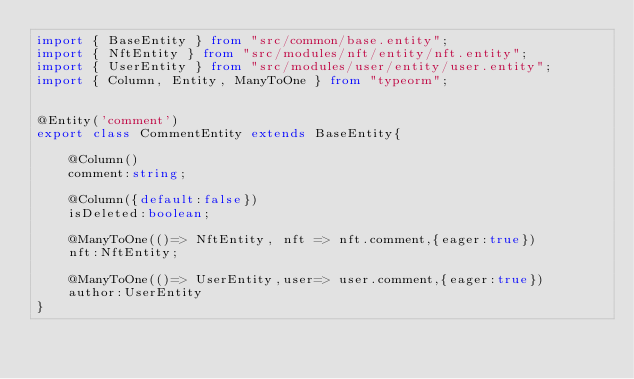<code> <loc_0><loc_0><loc_500><loc_500><_TypeScript_>import { BaseEntity } from "src/common/base.entity";
import { NftEntity } from "src/modules/nft/entity/nft.entity";
import { UserEntity } from "src/modules/user/entity/user.entity";
import { Column, Entity, ManyToOne } from "typeorm";


@Entity('comment')
export class CommentEntity extends BaseEntity{

    @Column()
    comment:string;

    @Column({default:false})
    isDeleted:boolean;

    @ManyToOne(()=> NftEntity, nft => nft.comment,{eager:true})
    nft:NftEntity;

    @ManyToOne(()=> UserEntity,user=> user.comment,{eager:true})
    author:UserEntity
}</code> 